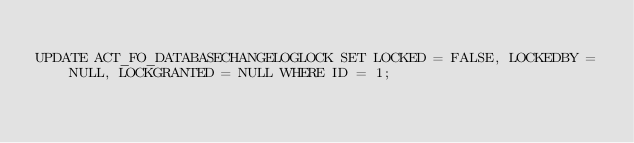Convert code to text. <code><loc_0><loc_0><loc_500><loc_500><_SQL_>
UPDATE ACT_FO_DATABASECHANGELOGLOCK SET LOCKED = FALSE, LOCKEDBY = NULL, LOCKGRANTED = NULL WHERE ID = 1;

</code> 